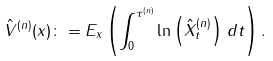Convert formula to latex. <formula><loc_0><loc_0><loc_500><loc_500>\hat { V } ^ { ( n ) } ( x ) \colon = E _ { x } \left ( \int _ { 0 } ^ { \tau ^ { ( n ) } } \ln \left ( \hat { X } ^ { ( n ) } _ { t } \right ) \, d t \right ) .</formula> 